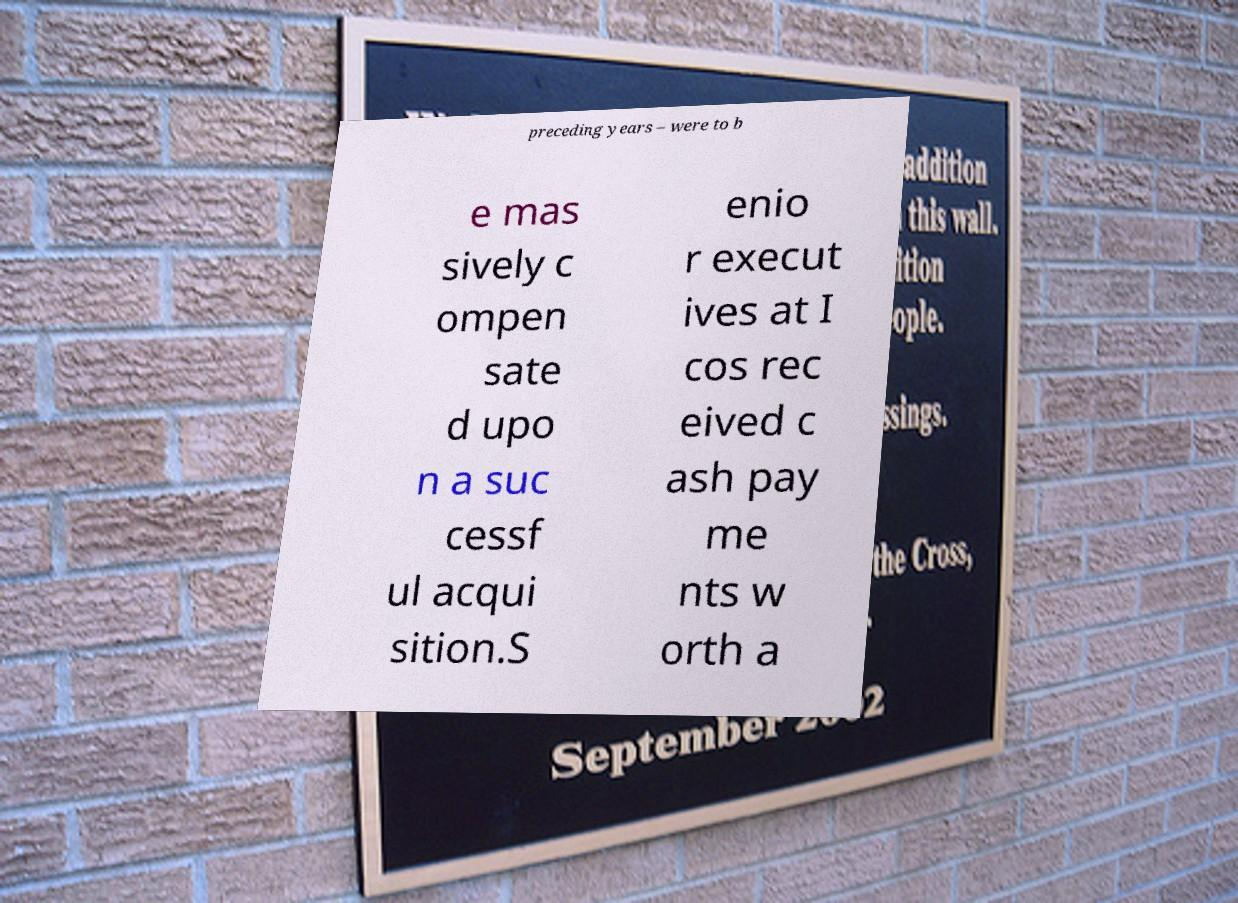There's text embedded in this image that I need extracted. Can you transcribe it verbatim? preceding years – were to b e mas sively c ompen sate d upo n a suc cessf ul acqui sition.S enio r execut ives at I cos rec eived c ash pay me nts w orth a 